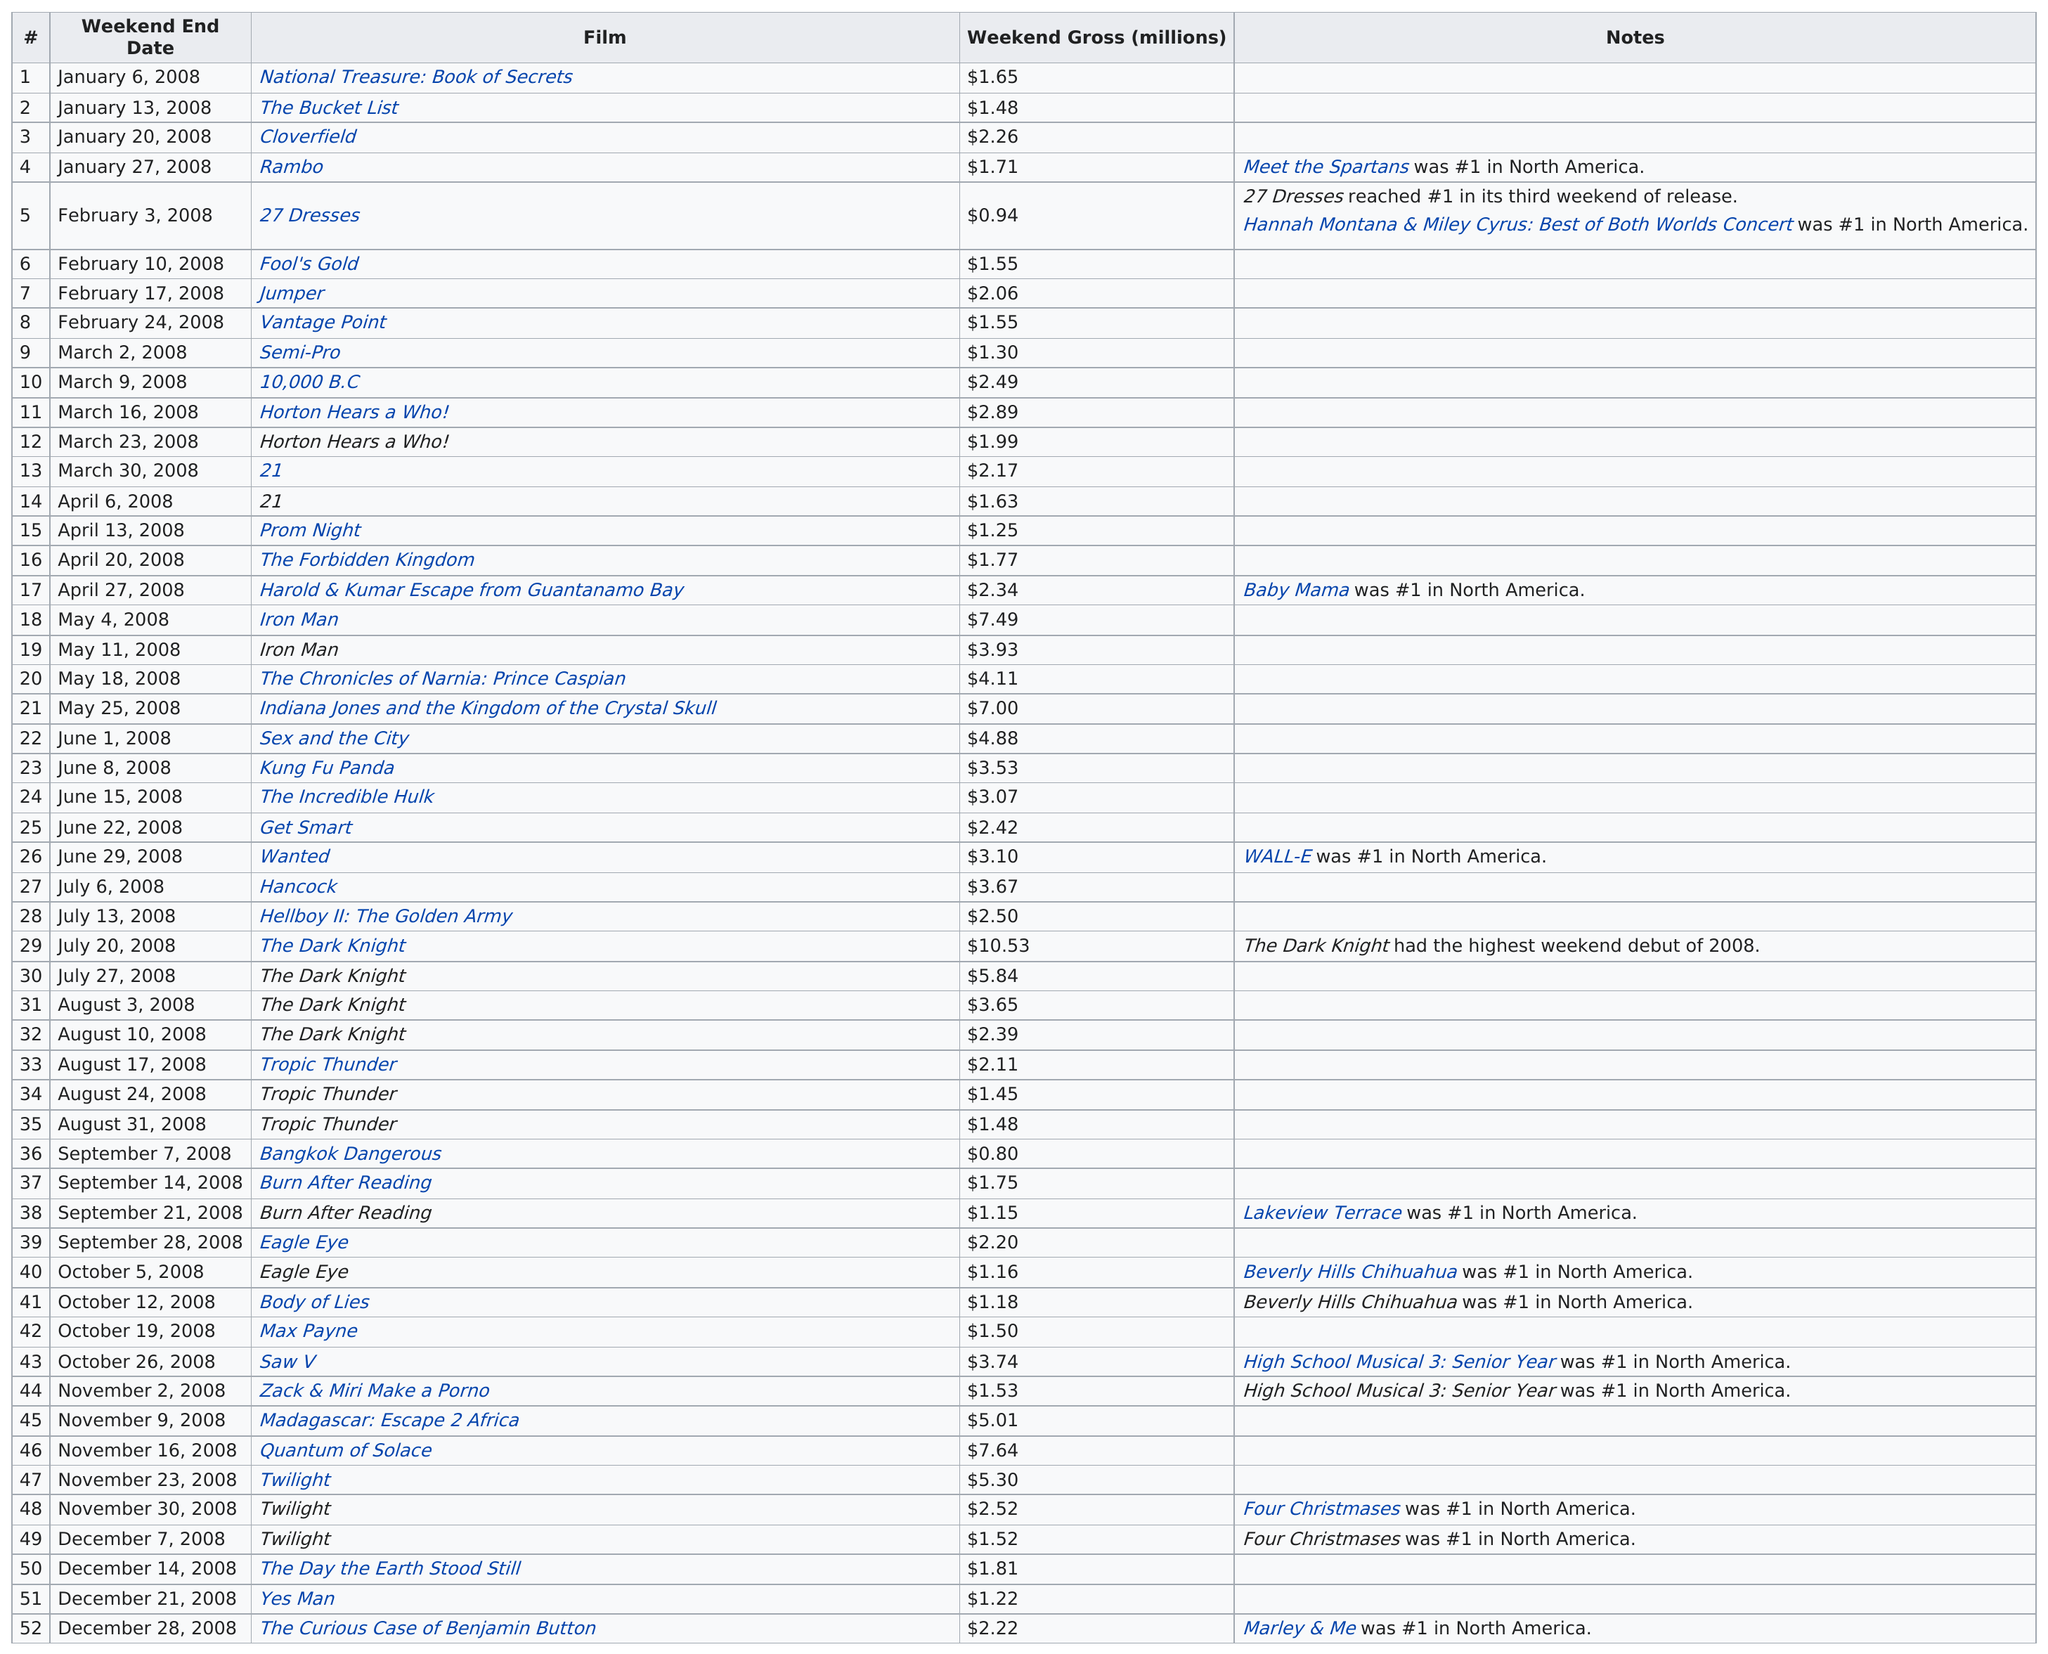Mention a couple of crucial points in this snapshot. The Dark Knight is the movie that grossed the highest amount of money in one weekend. Six films grossed over five million in their first week. In addition to "Beverly Hills Chihuahua" and "Four Christmases," another film spent more than one week as the number 1 movie in North America. Specifically, "High School Musical 3: Senior Year" held the top spot for multiple weeks. The Dark Knight was the highest grossing film for the most consecutive weekends. The last film of the year was "The Curious Case of Benjamin Button. 